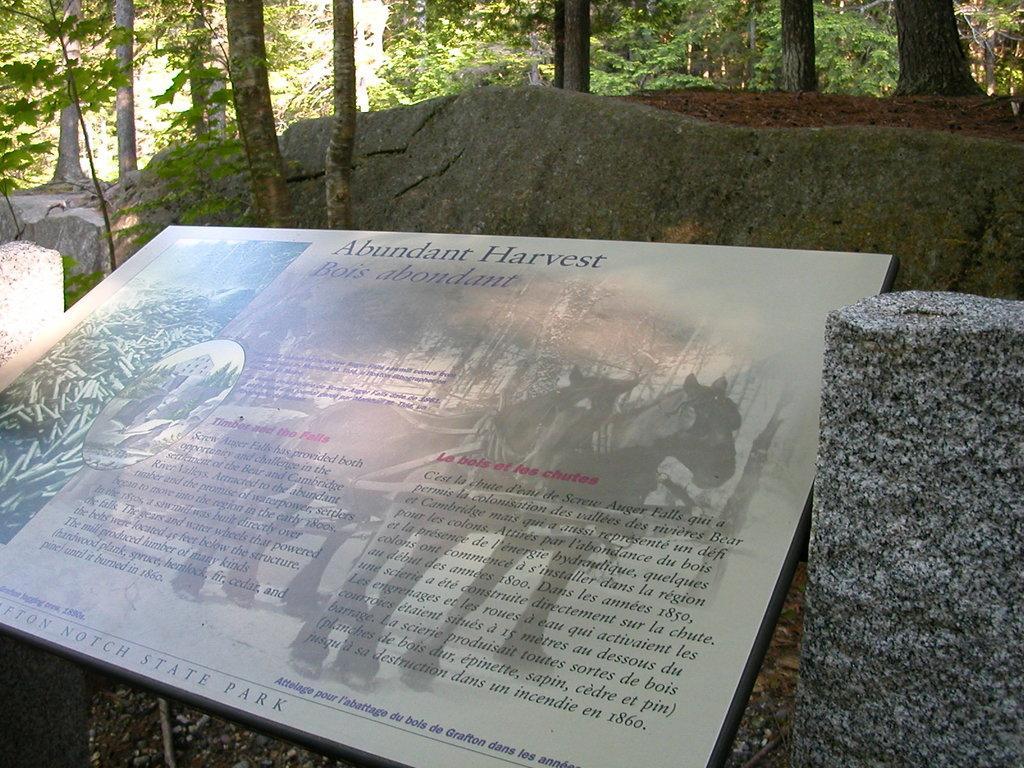Describe this image in one or two sentences. This is the picture of a board on which there are some pictures of animal and something written on it and around there are some trees, plants and rocks. 